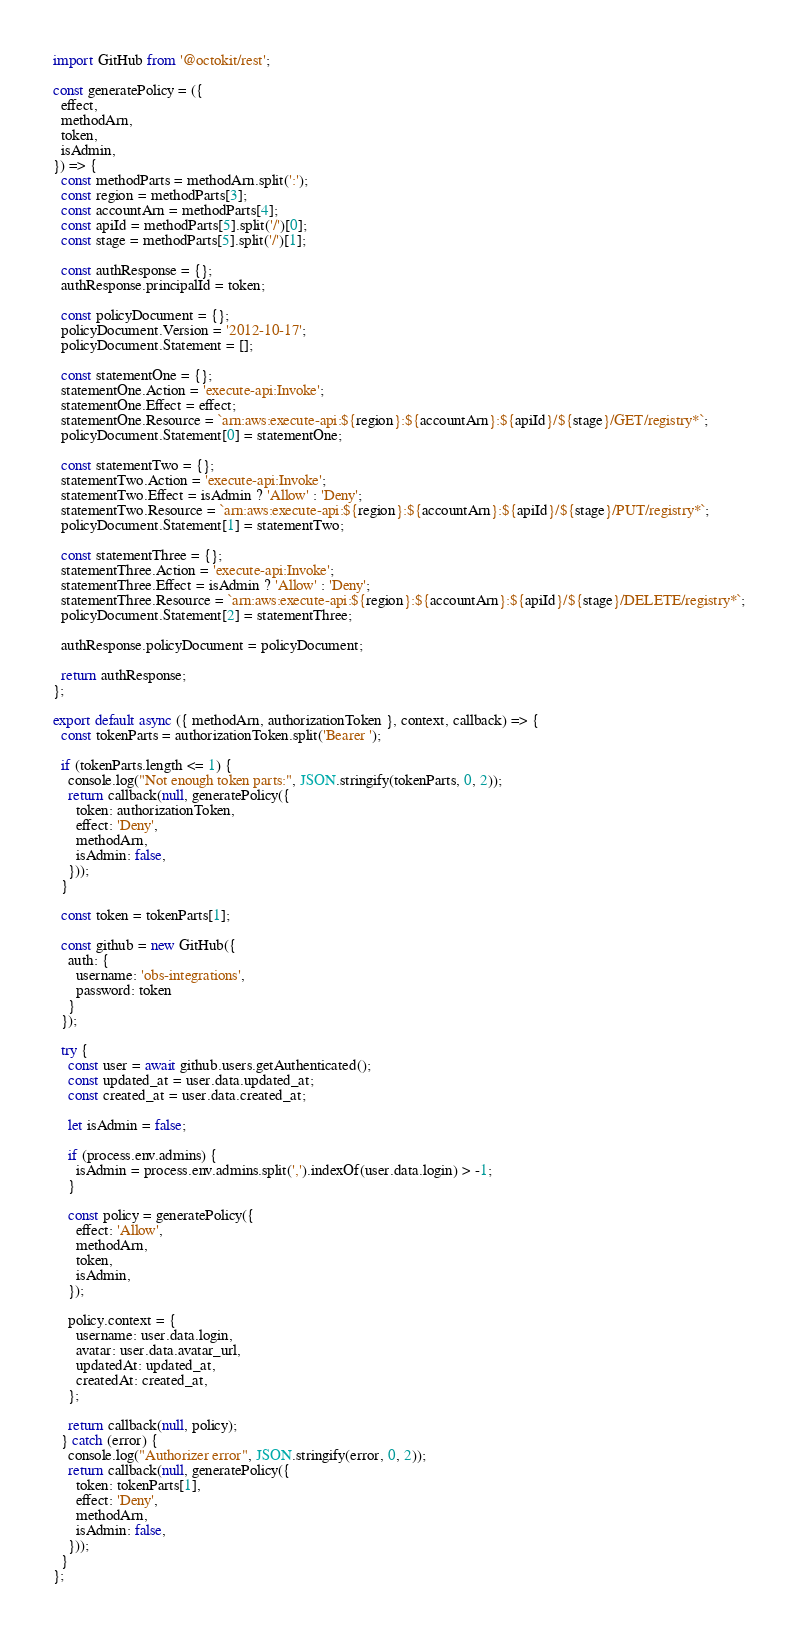<code> <loc_0><loc_0><loc_500><loc_500><_JavaScript_>import GitHub from '@octokit/rest';

const generatePolicy = ({
  effect,
  methodArn,
  token,
  isAdmin,
}) => {
  const methodParts = methodArn.split(':');
  const region = methodParts[3];
  const accountArn = methodParts[4];
  const apiId = methodParts[5].split('/')[0];
  const stage = methodParts[5].split('/')[1];

  const authResponse = {};
  authResponse.principalId = token;

  const policyDocument = {};
  policyDocument.Version = '2012-10-17';
  policyDocument.Statement = [];

  const statementOne = {};
  statementOne.Action = 'execute-api:Invoke';
  statementOne.Effect = effect;
  statementOne.Resource = `arn:aws:execute-api:${region}:${accountArn}:${apiId}/${stage}/GET/registry*`;
  policyDocument.Statement[0] = statementOne;

  const statementTwo = {};
  statementTwo.Action = 'execute-api:Invoke';
  statementTwo.Effect = isAdmin ? 'Allow' : 'Deny';
  statementTwo.Resource = `arn:aws:execute-api:${region}:${accountArn}:${apiId}/${stage}/PUT/registry*`;
  policyDocument.Statement[1] = statementTwo;

  const statementThree = {};
  statementThree.Action = 'execute-api:Invoke';
  statementThree.Effect = isAdmin ? 'Allow' : 'Deny';
  statementThree.Resource = `arn:aws:execute-api:${region}:${accountArn}:${apiId}/${stage}/DELETE/registry*`;
  policyDocument.Statement[2] = statementThree;

  authResponse.policyDocument = policyDocument;

  return authResponse;
};

export default async ({ methodArn, authorizationToken }, context, callback) => {
  const tokenParts = authorizationToken.split('Bearer ');

  if (tokenParts.length <= 1) {
    console.log("Not enough token parts:", JSON.stringify(tokenParts, 0, 2));
    return callback(null, generatePolicy({
      token: authorizationToken,
      effect: 'Deny',
      methodArn,
      isAdmin: false,
    }));
  }

  const token = tokenParts[1];

  const github = new GitHub({
    auth: {
      username: 'obs-integrations',
      password: token
    }
  });

  try {
    const user = await github.users.getAuthenticated();
    const updated_at = user.data.updated_at;
    const created_at = user.data.created_at;

    let isAdmin = false;

    if (process.env.admins) {
      isAdmin = process.env.admins.split(',').indexOf(user.data.login) > -1;
    }

    const policy = generatePolicy({
      effect: 'Allow',
      methodArn,
      token,
      isAdmin,
    });

    policy.context = {
      username: user.data.login,
      avatar: user.data.avatar_url,
      updatedAt: updated_at,
      createdAt: created_at,
    };

    return callback(null, policy);
  } catch (error) {
    console.log("Authorizer error", JSON.stringify(error, 0, 2));
    return callback(null, generatePolicy({
      token: tokenParts[1],
      effect: 'Deny',
      methodArn,
      isAdmin: false,
    }));
  }
};
</code> 